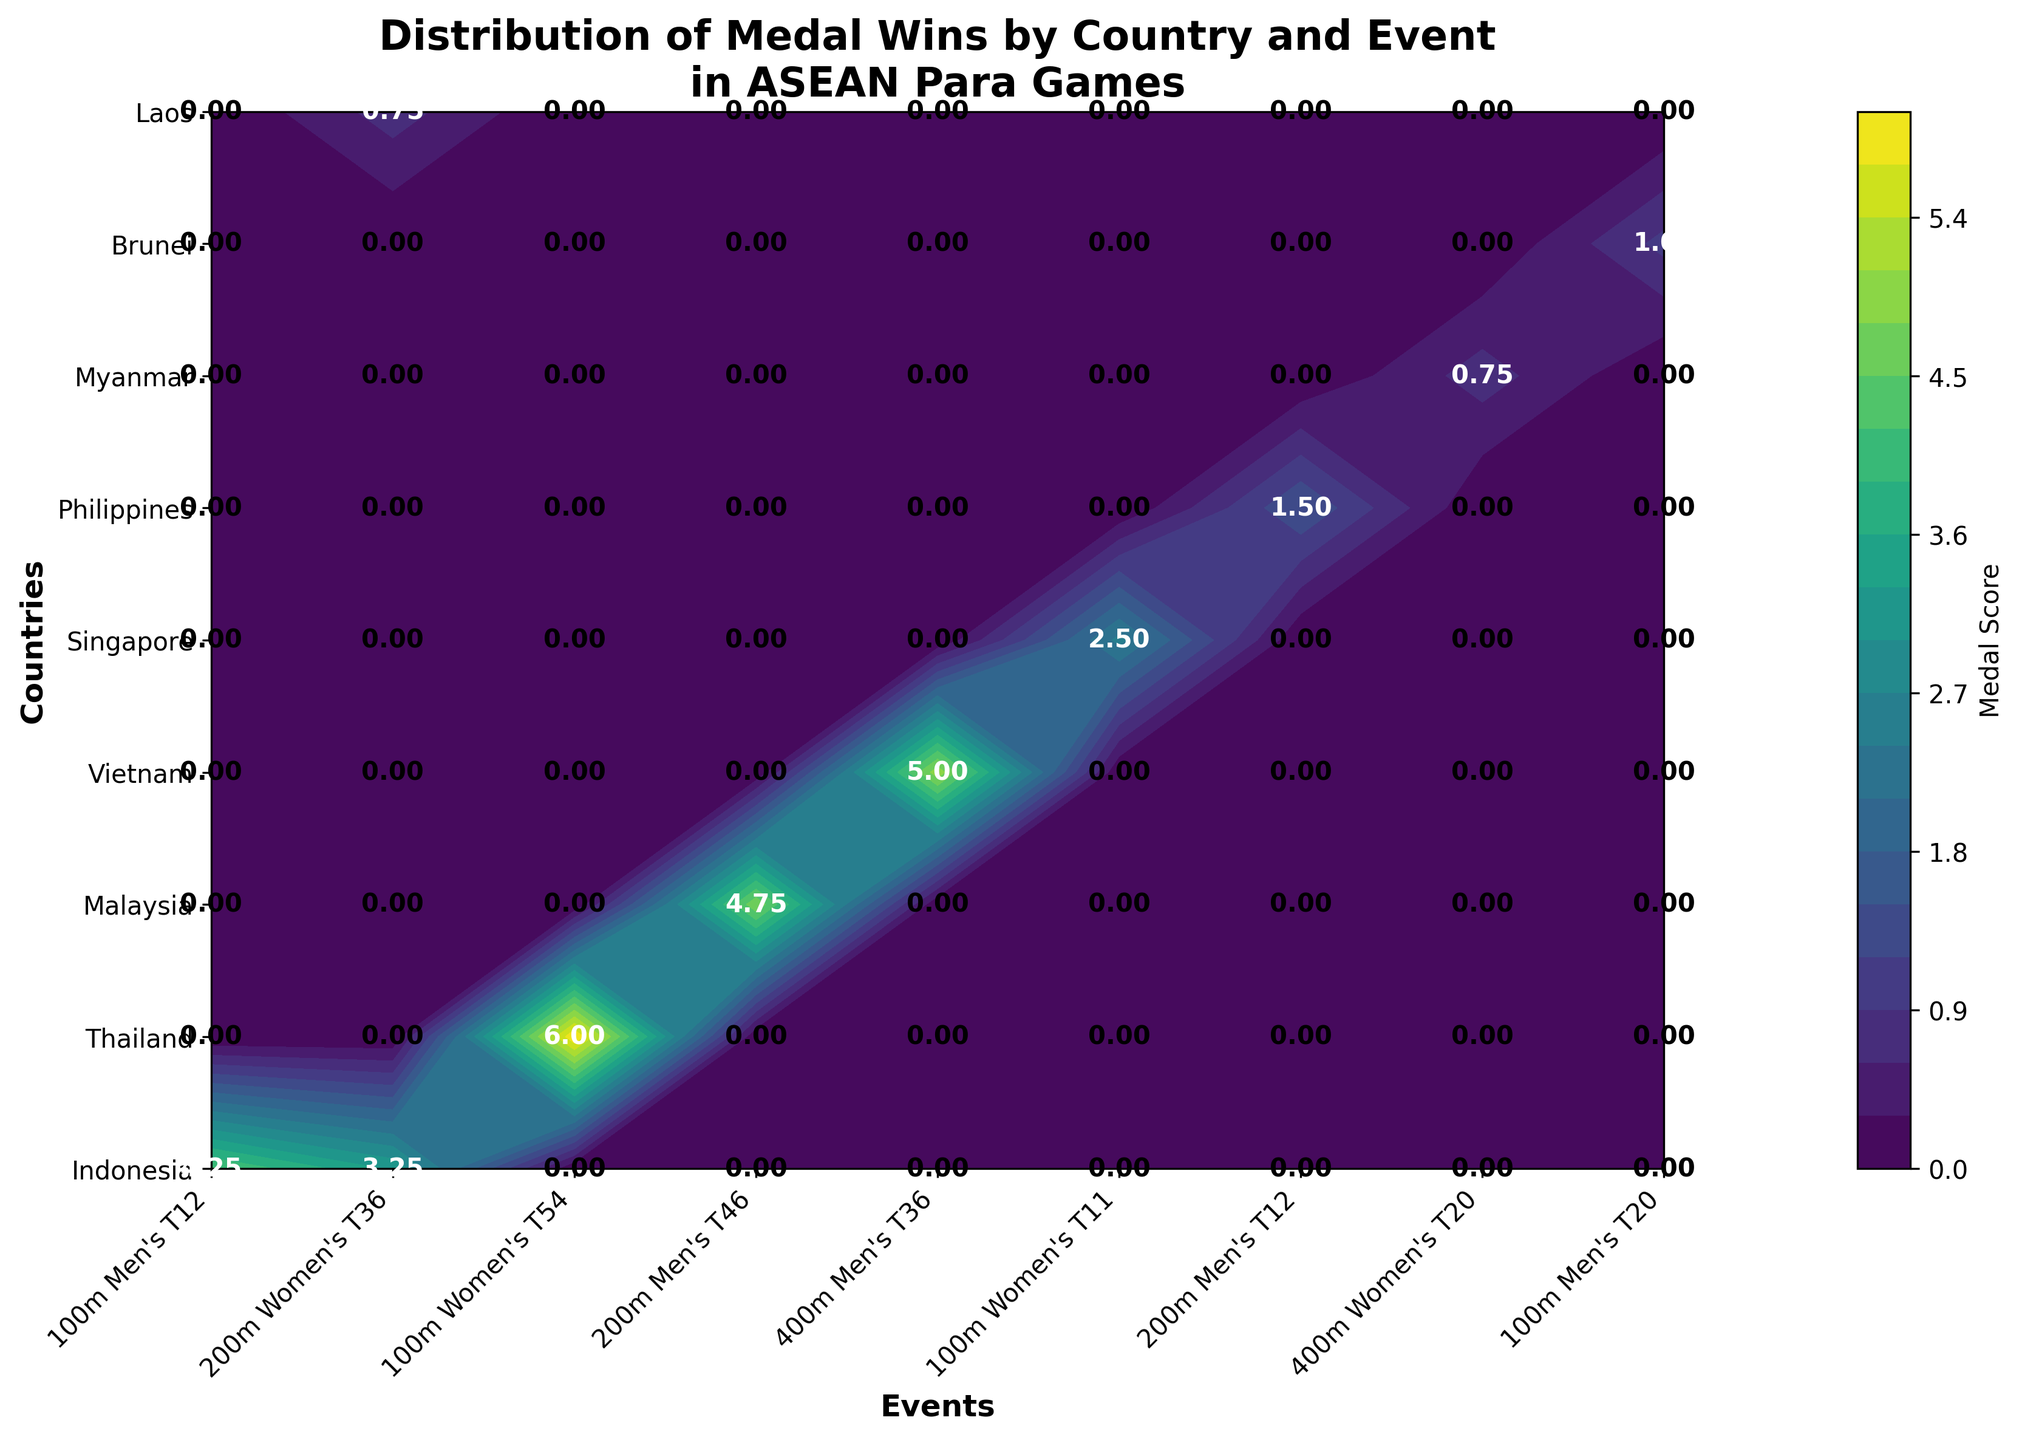What is the title of the figure? The title of the figure is displayed prominently at the top of the plot.
Answer: Distribution of Medal Wins by Country and Event in ASEAN Para Games Which country appears to have the highest overall medal score? By examining the color gradient on the contour plot, Thailand stands out with the highest intensity colors across multiple events.
Answer: Thailand What do the different colors on the contour plot represent? The colors represent different levels of medal scores, with darker colors indicating higher scores.
Answer: Medal Scores How many events are displayed on the x-axis of the plot? Count the unique event categories labeled on the x-axis. There are 8 events labeled.
Answer: 8 Which event has a higher medal score for Malaysia: 200m Men's T46 or 100m Men's T12? Compare the color intensity and the text annotation within the cells corresponding to Malaysia for both events. The score for 200m Men's T46 is higher.
Answer: 200m Men's T46 Which country earned the most medals in the 100m Women's T54 event? Locate the 100m Women's T54 event on the x-axis and then find the darkest area in the corresponding column. Thailand has the darkest shade, indicating the highest score.
Answer: Thailand What is the medal score for Indonesia in the 200m Women's T36 event, and how is it calculated? Find the score annotation in the cell for Indonesia and 200m Women's T36. The score is calculated as (Gold * 1) + (Silver * 0.5) + (Bronze * 0.25) = (2 * 1) + (1 * 0.5) + (3 * 0.25) = 2 + 0.5 + 0.75 = 3.25.
Answer: 3.25 Which country has the least total medal scores across all events? By checking the overall color intensity and values annotated on the figure, Myanmar shows the lowest scores across all events.
Answer: Myanmar Comparing neighbors, does Indonesia have a higher medal score in 400m Men's T36 than Vietnam? Compare the text annotations for Indonesia and Vietnam in the 400m Men's T36 column. Indonesia's score is lower than Vietnam's.
Answer: No What is the medal score difference between Brunei and Singapore in the 100m Men's T20 event? Identify the score annotations for Brunei and Singapore in the 100m Men's T20 cell and subtract Brunei’s score from Singapore’s score: (Brunei’s score of 1.0 - Singapore’s score of 0) = 1.0.
Answer: 1.0 